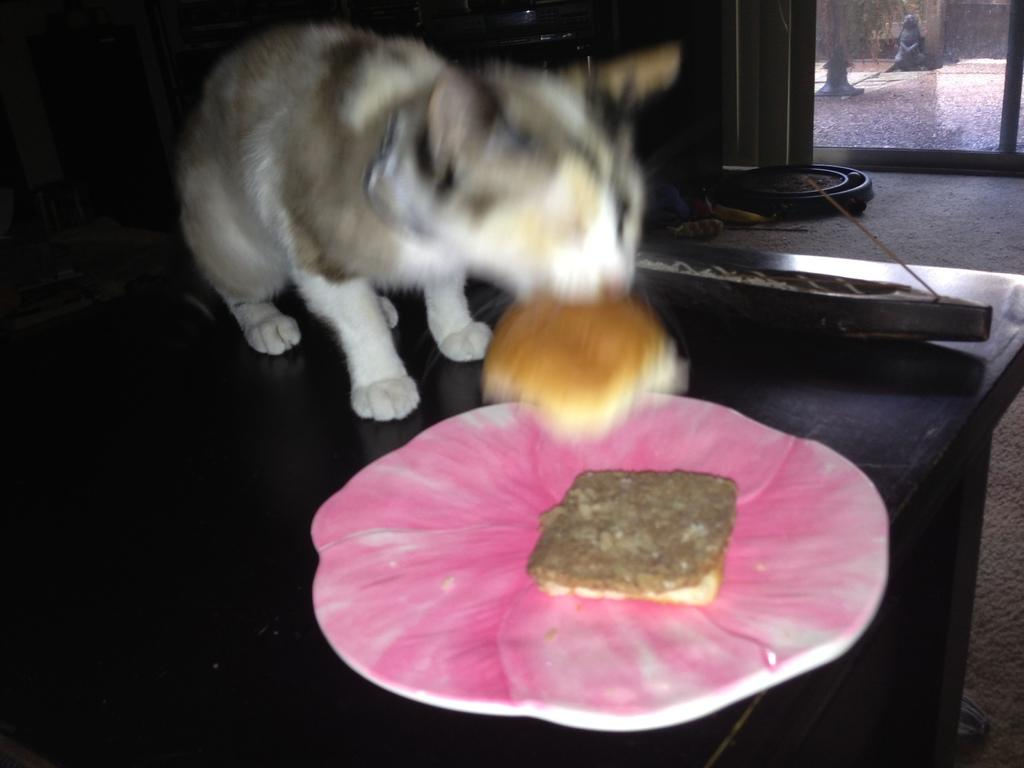What animal can be seen in the image? There is a cat in the image. What is the cat doing with its mouth? The cat is holding a bread in its mouth. What object is in front of the cat? There is a pink plate in front of the cat. What type of door can be seen in the image? There is a glass door in the right corner of the image. How many toes does the canvas have in the image? There is no canvas present in the image, and therefore no toes can be counted. 